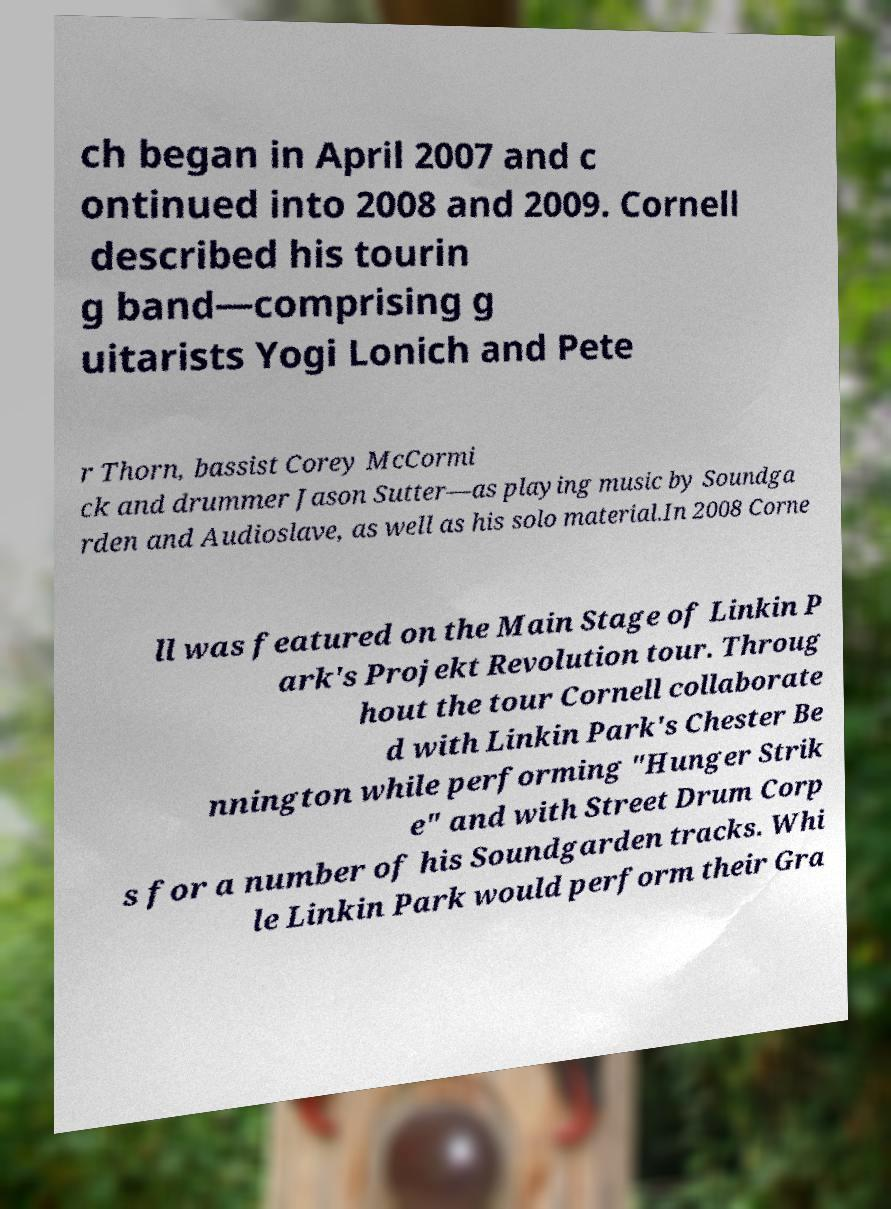Please identify and transcribe the text found in this image. ch began in April 2007 and c ontinued into 2008 and 2009. Cornell described his tourin g band—comprising g uitarists Yogi Lonich and Pete r Thorn, bassist Corey McCormi ck and drummer Jason Sutter—as playing music by Soundga rden and Audioslave, as well as his solo material.In 2008 Corne ll was featured on the Main Stage of Linkin P ark's Projekt Revolution tour. Throug hout the tour Cornell collaborate d with Linkin Park's Chester Be nnington while performing "Hunger Strik e" and with Street Drum Corp s for a number of his Soundgarden tracks. Whi le Linkin Park would perform their Gra 